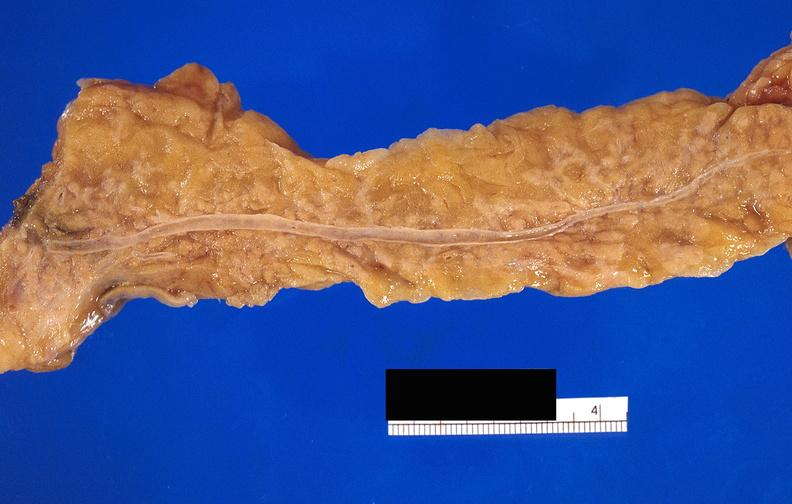does underdevelopment show pancreatic fat necrosis?
Answer the question using a single word or phrase. No 